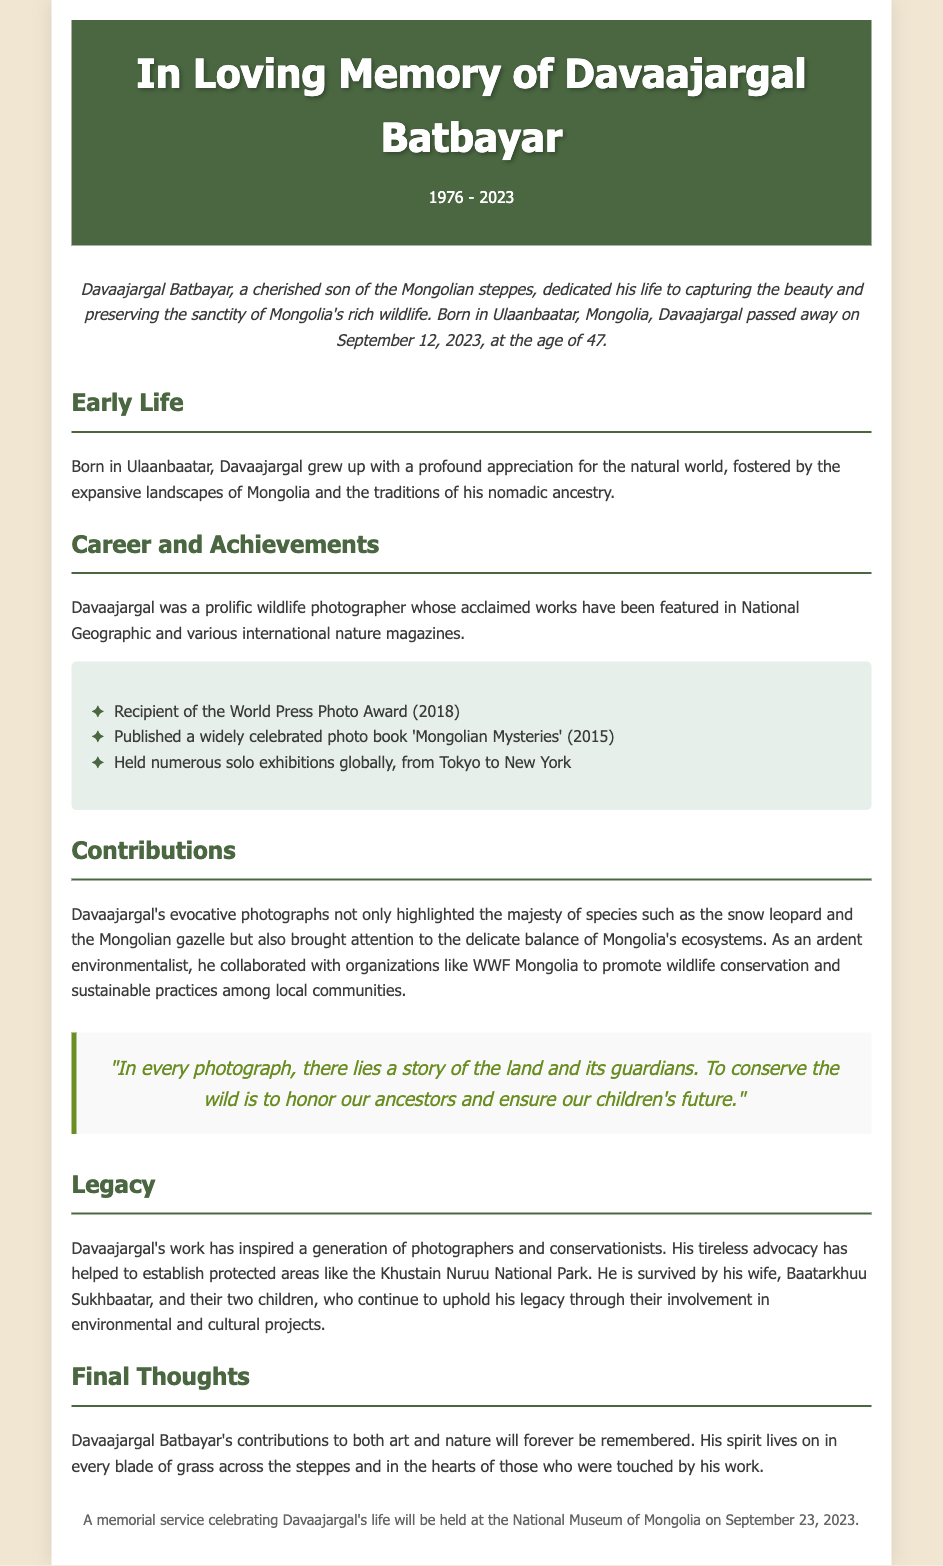what was Davaajargal's age at passing? The document states that Davaajargal passed away at the age of 47.
Answer: 47 what prestigious award did Davaajargal receive? The document mentions that he was the recipient of the World Press Photo Award.
Answer: World Press Photo Award when was Davaajargal's photo book published? The document states that 'Mongolian Mysteries' was published in 2015.
Answer: 2015 who survived Davaajargal? The document lists his wife, Baatarkhuu Sukhbaatar, and their two children as survivors.
Answer: Baatarkhuu Sukhbaatar and their two children what type of conservation organization did Davaajargal collaborate with? The document includes that he collaborated with WWF Mongolia.
Answer: WWF Mongolia what is the purpose of the memorial service mentioned? The document describes the memorial service as a celebration of Davaajargal's life.
Answer: Celebration of Davaajargal's life how did Davaajargal contribute to the environment? The document explains that he promoted wildlife conservation and sustainable practices.
Answer: Promoted wildlife conservation and sustainable practices what kind of photographer was Davaajargal described as? The document describes him as a prolific wildlife photographer.
Answer: Prolific wildlife photographer 